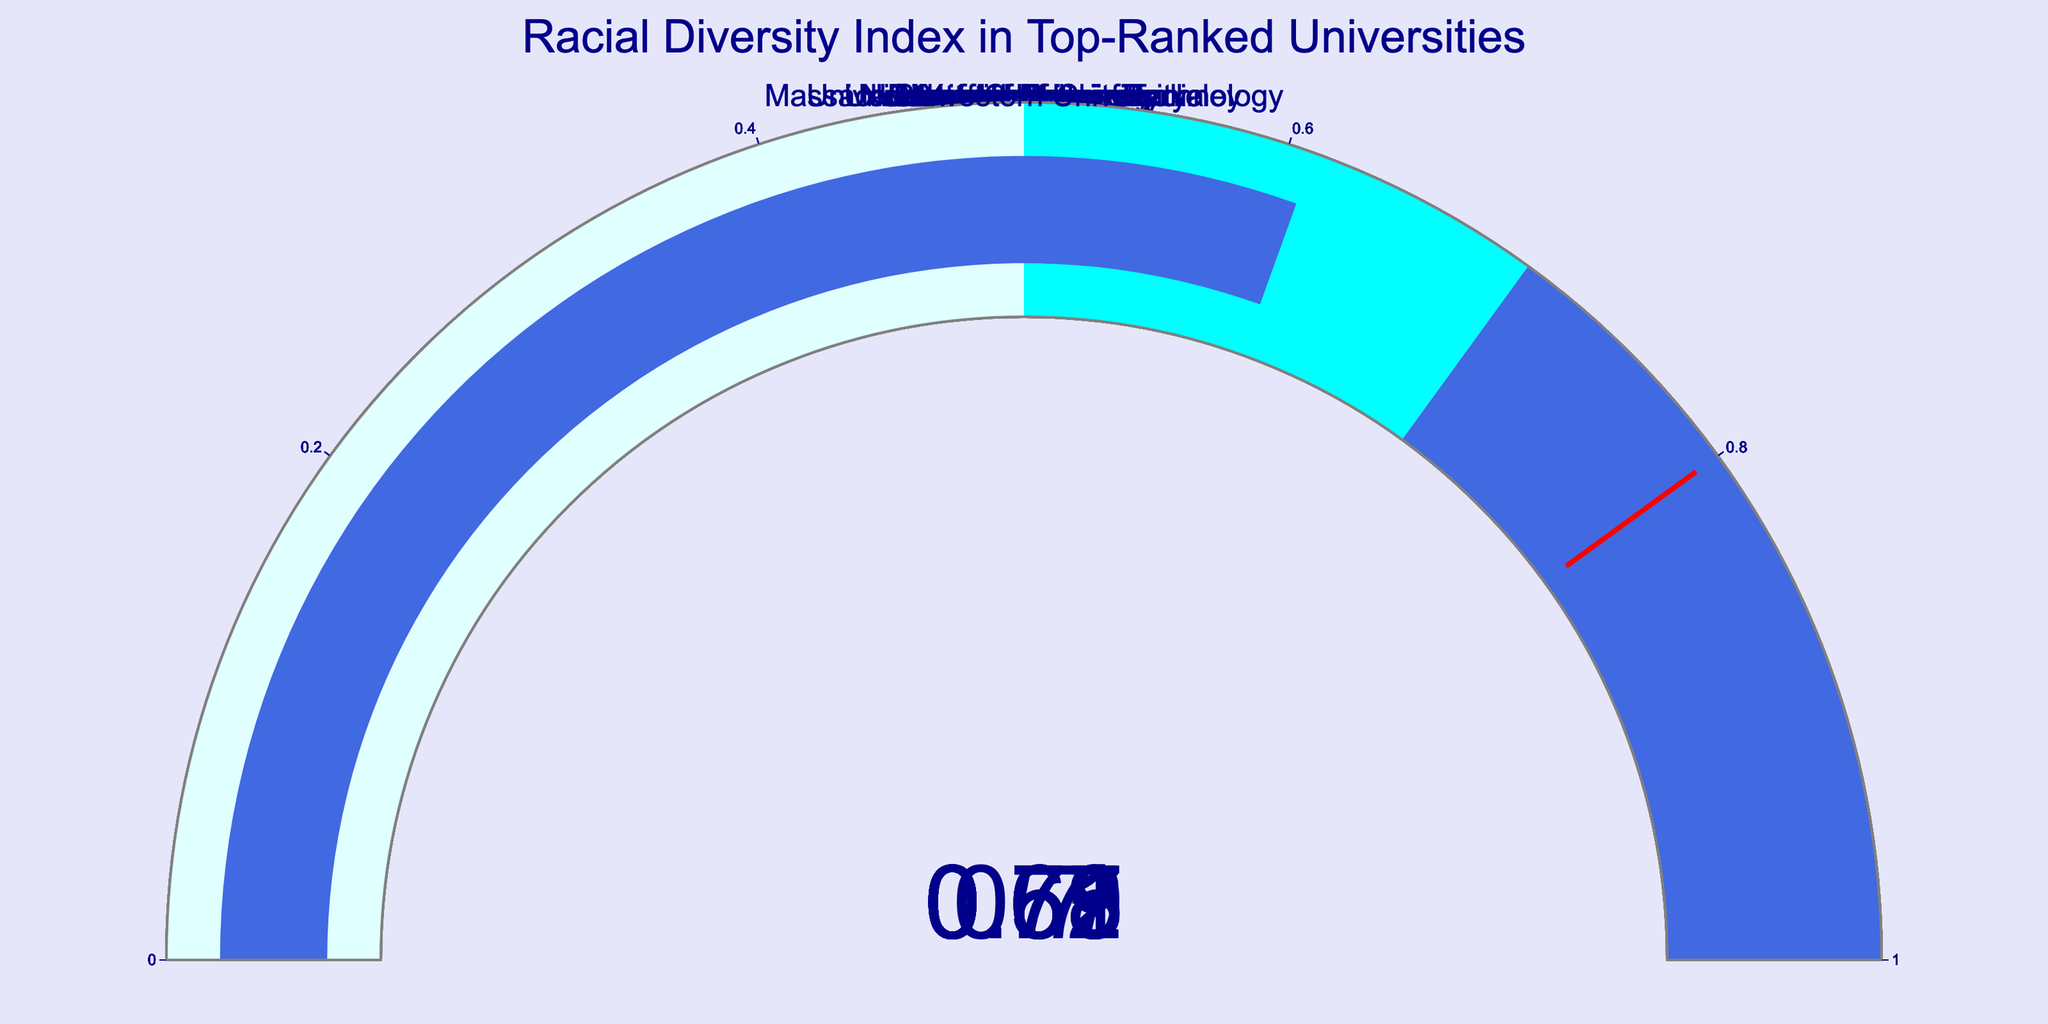What is the title of the figure? The title is prominently displayed at the top of the figure in large font size, and it reads "Racial Diversity Index in Top-Ranked Universities".
Answer: Racial Diversity Index in Top-Ranked Universities Which university has the highest Diversity Index? The figure shows multiple gauges for different universities, and the one with the highest value on the gauge is "University of California Berkeley", which has a Diversity Index of 0.78.
Answer: University of California Berkeley How many universities have a Diversity Index greater than 0.7? Looking at the gauges, the universities with Diversity Indices greater than 0.7 are Harvard University (0.72), Yale University (0.70), Columbia University (0.71), and University of California Berkeley (0.78). That makes a total of 4 universities.
Answer: 4 Which university has the lowest Diversity Index? Among all the displayed gauges, the University of Chicago has the lowest Diversity Index, which is 0.59.
Answer: University of Chicago What is the range of Diversity Index values shown in the figure? The figure displays the Diversity Index values for different universities, ranging from the lowest at 0.59 (University of Chicago) to the highest at 0.78 (University of California Berkeley). The range is therefore 0.78 - 0.59.
Answer: 0.19 Which universities have a Diversity Index between 0.6 and 0.7? Upon inspecting the gauges, the universities with Diversity Indices between 0.6 and 0.7 are Columbia University (0.61), Massachusetts Institute of Technology (0.65), Princeton University (0.63), and University of Pennsylvania (0.67).
Answer: Columbia University, MIT, Princeton University, University of Pennsylvania How many steps are used in the gauge color gradient? Each gauge displays a gradient with distinct steps marked by different colors. By observing the color changes, there are three visible steps: lightcyan (0 to 0.5), cyan (0.5 to 0.7), and royalblue (0.7 to 1).
Answer: 3 Which universities have a Diversity Index lower than 0.65? The gauges show that the universities with a Diversity Index lower than 0.65 include Princeton University (0.63), University of Chicago (0.59), and Northwestern University (0.61).
Answer: Princeton University, University of Chicago, Northwestern University 